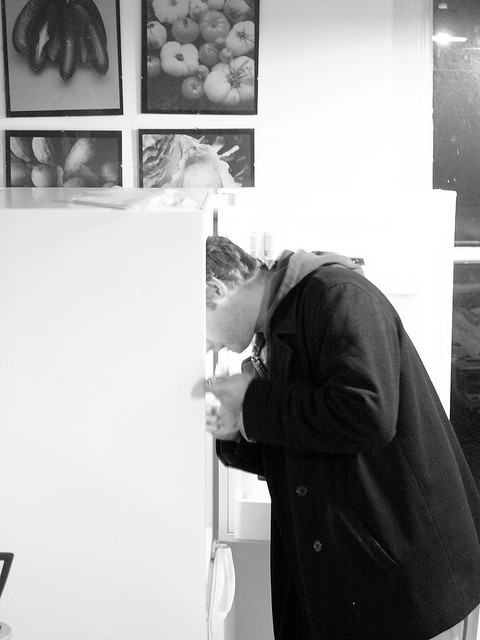<image>What is the man looking into? I don't know what the man is looking into. It could be a refrigerator, fridge, box, freezer, or cupboard. What is the man looking into? The man is looking into the refrigerator. 